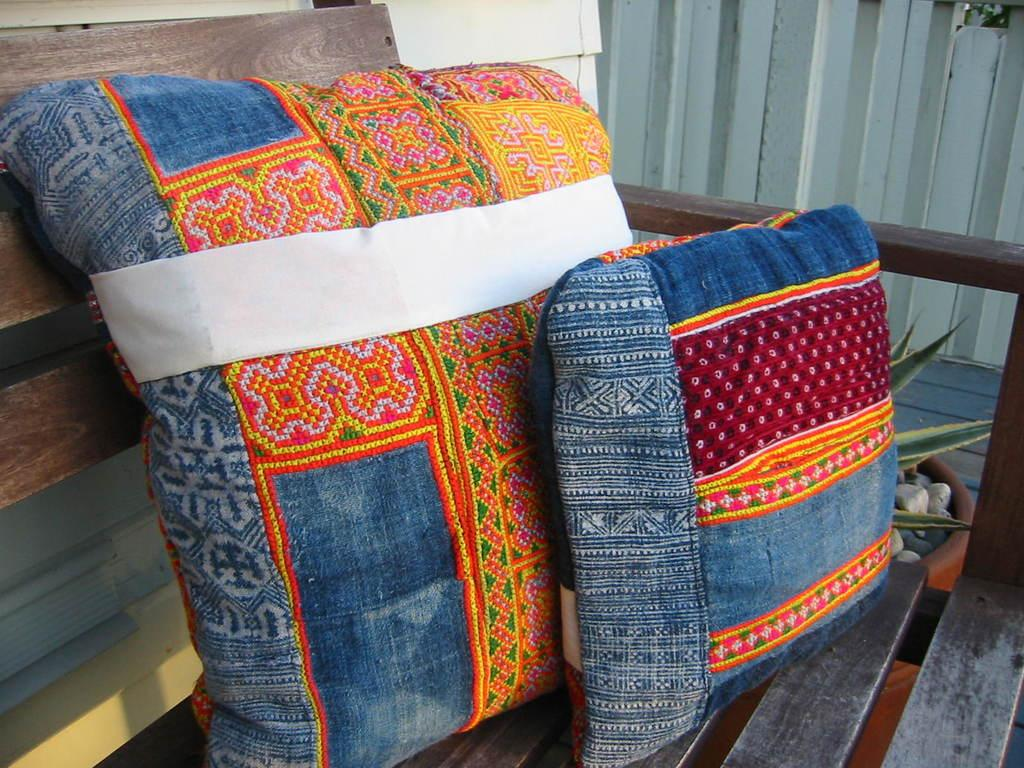What is on the chair in the image? There are pillows on the chair. What can be seen beside the chair? There is a potted plant beside the chair. What is visible in the background of the image? There is a wall in the background of the image. What is the income of the person who owns the chair in the image? There is no information about the income of the person who owns the chair in the image. What color is the orange on the chair in the image? There is no orange present in the image; it features pillows and a potted plant. 